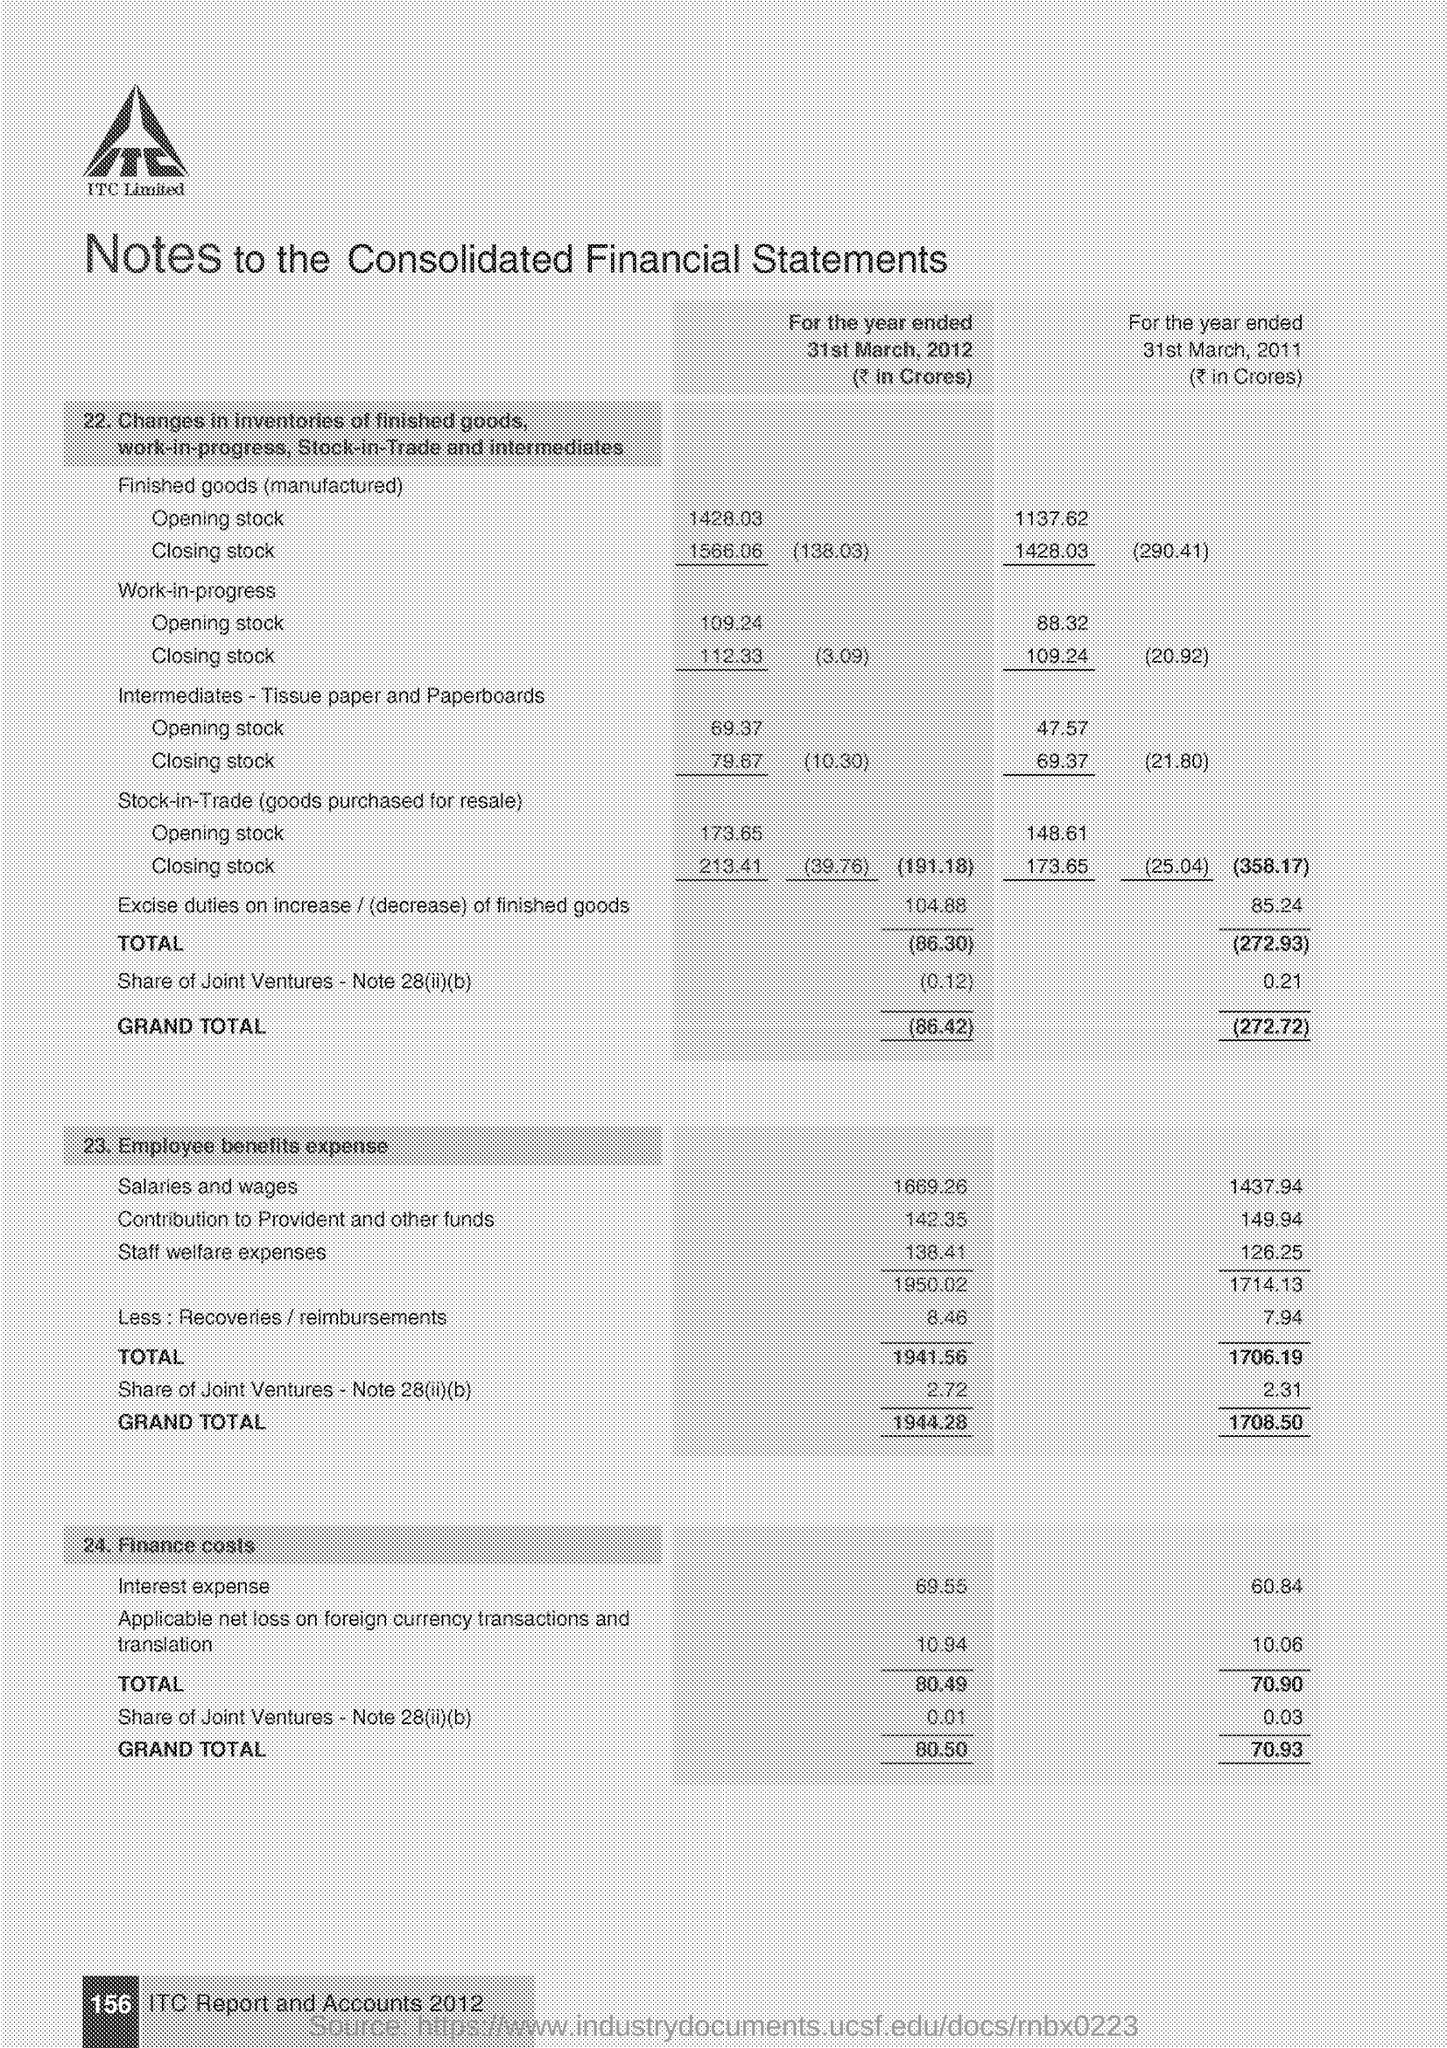What is the opening stock for the finished goods (manufactured )for the year ended 31st march,2012(in crores)
Make the answer very short. 1428.03. What is the opening stock for the finished goods (manufactured )for the year ended 31st march,2011(in crores)
Keep it short and to the point. 1137.62. What is the grand total of employee benefits expense for the year ended 31st march , 2012(in crores)
Ensure brevity in your answer.  1944.28. What is the grand total of employee benefits expense for the year ended 31st march , 2011(in crores)
Provide a succinct answer. 1708.50. What is the grand total of finance costs  for the year ended 31st march , 2012(in crores)
Ensure brevity in your answer.  80.50. What is the grand total of finance costs  for the year ended 31st march , 2011(in crores)
Give a very brief answer. 70.93. 